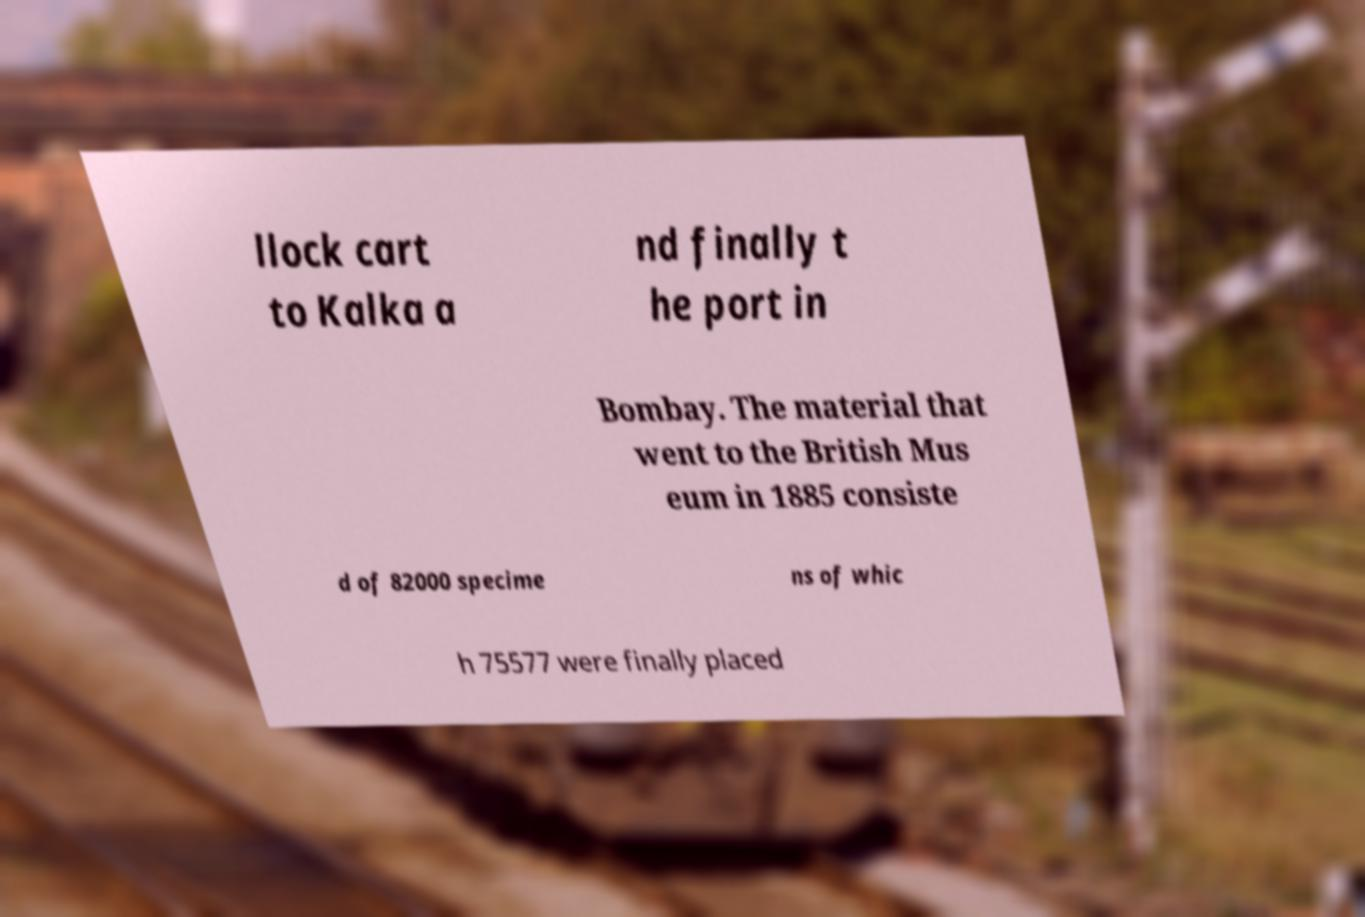I need the written content from this picture converted into text. Can you do that? llock cart to Kalka a nd finally t he port in Bombay. The material that went to the British Mus eum in 1885 consiste d of 82000 specime ns of whic h 75577 were finally placed 